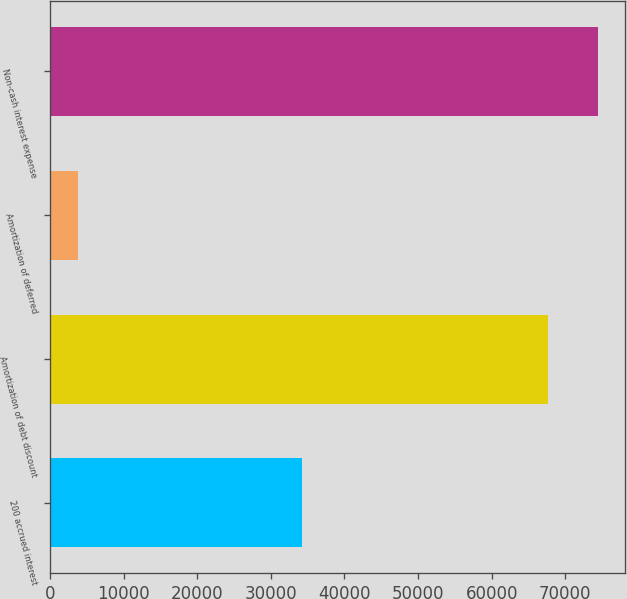Convert chart. <chart><loc_0><loc_0><loc_500><loc_500><bar_chart><fcel>200 accrued interest<fcel>Amortization of debt discount<fcel>Amortization of deferred<fcel>Non-cash interest expense<nl><fcel>34269<fcel>67673<fcel>3786<fcel>74440.3<nl></chart> 